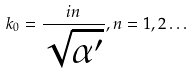<formula> <loc_0><loc_0><loc_500><loc_500>k _ { 0 } = \frac { i n } { \sqrt { \alpha ^ { \prime } } } , n = 1 , 2 \dots</formula> 